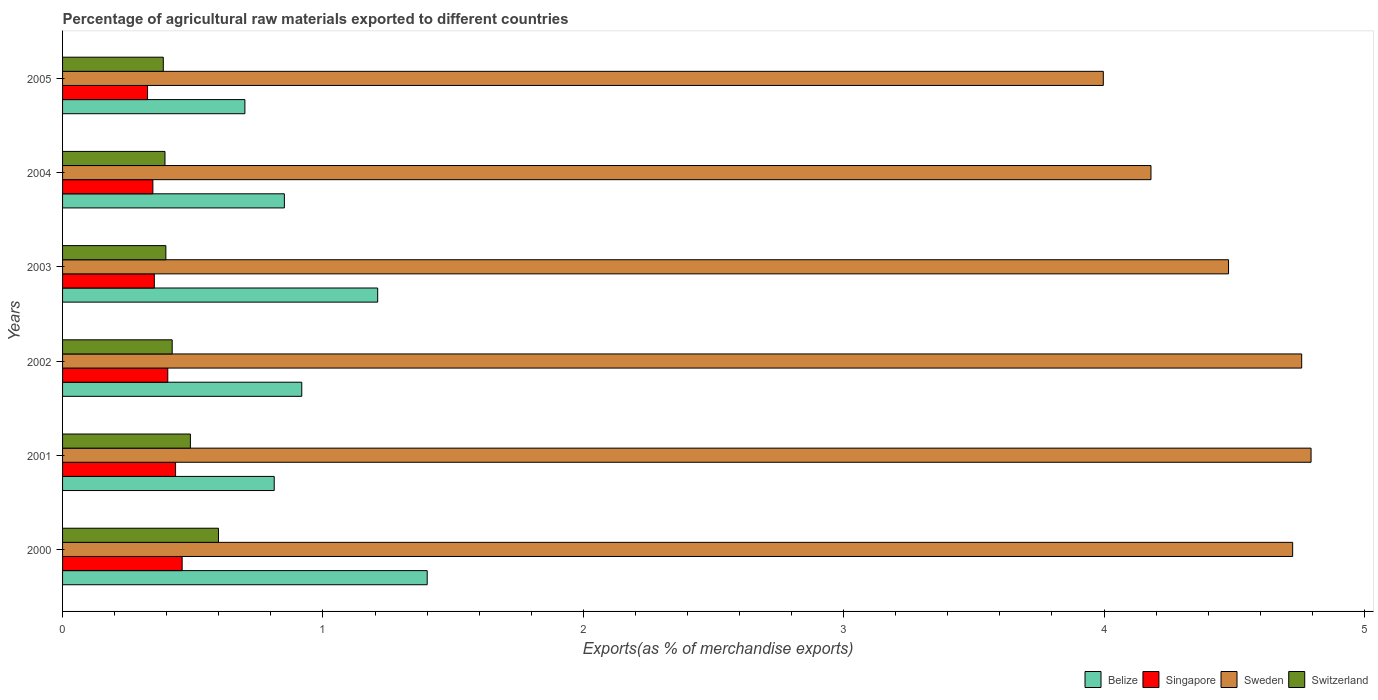How many different coloured bars are there?
Keep it short and to the point. 4. Are the number of bars per tick equal to the number of legend labels?
Make the answer very short. Yes. Are the number of bars on each tick of the Y-axis equal?
Give a very brief answer. Yes. How many bars are there on the 1st tick from the top?
Your answer should be very brief. 4. In how many cases, is the number of bars for a given year not equal to the number of legend labels?
Offer a terse response. 0. What is the percentage of exports to different countries in Sweden in 2004?
Ensure brevity in your answer.  4.18. Across all years, what is the maximum percentage of exports to different countries in Switzerland?
Provide a succinct answer. 0.6. Across all years, what is the minimum percentage of exports to different countries in Sweden?
Give a very brief answer. 4. In which year was the percentage of exports to different countries in Sweden minimum?
Keep it short and to the point. 2005. What is the total percentage of exports to different countries in Singapore in the graph?
Your response must be concise. 2.32. What is the difference between the percentage of exports to different countries in Singapore in 2001 and that in 2005?
Your answer should be very brief. 0.11. What is the difference between the percentage of exports to different countries in Singapore in 2000 and the percentage of exports to different countries in Sweden in 2002?
Keep it short and to the point. -4.3. What is the average percentage of exports to different countries in Sweden per year?
Your answer should be compact. 4.49. In the year 2000, what is the difference between the percentage of exports to different countries in Belize and percentage of exports to different countries in Singapore?
Your answer should be very brief. 0.94. What is the ratio of the percentage of exports to different countries in Singapore in 2002 to that in 2005?
Offer a very short reply. 1.24. Is the percentage of exports to different countries in Sweden in 2000 less than that in 2003?
Your answer should be very brief. No. Is the difference between the percentage of exports to different countries in Belize in 2001 and 2005 greater than the difference between the percentage of exports to different countries in Singapore in 2001 and 2005?
Make the answer very short. Yes. What is the difference between the highest and the second highest percentage of exports to different countries in Singapore?
Make the answer very short. 0.03. What is the difference between the highest and the lowest percentage of exports to different countries in Sweden?
Offer a terse response. 0.8. In how many years, is the percentage of exports to different countries in Switzerland greater than the average percentage of exports to different countries in Switzerland taken over all years?
Offer a very short reply. 2. Is it the case that in every year, the sum of the percentage of exports to different countries in Switzerland and percentage of exports to different countries in Sweden is greater than the sum of percentage of exports to different countries in Belize and percentage of exports to different countries in Singapore?
Provide a short and direct response. Yes. What does the 1st bar from the top in 2001 represents?
Provide a succinct answer. Switzerland. What does the 2nd bar from the bottom in 2003 represents?
Give a very brief answer. Singapore. How many bars are there?
Give a very brief answer. 24. How many years are there in the graph?
Provide a succinct answer. 6. Are the values on the major ticks of X-axis written in scientific E-notation?
Give a very brief answer. No. Does the graph contain grids?
Your answer should be compact. No. Where does the legend appear in the graph?
Your answer should be compact. Bottom right. How many legend labels are there?
Ensure brevity in your answer.  4. What is the title of the graph?
Offer a terse response. Percentage of agricultural raw materials exported to different countries. What is the label or title of the X-axis?
Provide a short and direct response. Exports(as % of merchandise exports). What is the Exports(as % of merchandise exports) of Belize in 2000?
Make the answer very short. 1.4. What is the Exports(as % of merchandise exports) of Singapore in 2000?
Make the answer very short. 0.46. What is the Exports(as % of merchandise exports) of Sweden in 2000?
Your response must be concise. 4.72. What is the Exports(as % of merchandise exports) of Switzerland in 2000?
Ensure brevity in your answer.  0.6. What is the Exports(as % of merchandise exports) of Belize in 2001?
Offer a terse response. 0.81. What is the Exports(as % of merchandise exports) of Singapore in 2001?
Ensure brevity in your answer.  0.43. What is the Exports(as % of merchandise exports) in Sweden in 2001?
Give a very brief answer. 4.8. What is the Exports(as % of merchandise exports) in Switzerland in 2001?
Offer a very short reply. 0.49. What is the Exports(as % of merchandise exports) of Belize in 2002?
Your answer should be compact. 0.92. What is the Exports(as % of merchandise exports) in Singapore in 2002?
Your answer should be very brief. 0.4. What is the Exports(as % of merchandise exports) in Sweden in 2002?
Give a very brief answer. 4.76. What is the Exports(as % of merchandise exports) in Switzerland in 2002?
Keep it short and to the point. 0.42. What is the Exports(as % of merchandise exports) in Belize in 2003?
Provide a succinct answer. 1.21. What is the Exports(as % of merchandise exports) of Singapore in 2003?
Your answer should be compact. 0.35. What is the Exports(as % of merchandise exports) in Sweden in 2003?
Your response must be concise. 4.48. What is the Exports(as % of merchandise exports) of Switzerland in 2003?
Provide a succinct answer. 0.4. What is the Exports(as % of merchandise exports) in Belize in 2004?
Offer a terse response. 0.85. What is the Exports(as % of merchandise exports) in Singapore in 2004?
Give a very brief answer. 0.35. What is the Exports(as % of merchandise exports) of Sweden in 2004?
Keep it short and to the point. 4.18. What is the Exports(as % of merchandise exports) in Switzerland in 2004?
Ensure brevity in your answer.  0.39. What is the Exports(as % of merchandise exports) of Belize in 2005?
Keep it short and to the point. 0.7. What is the Exports(as % of merchandise exports) of Singapore in 2005?
Provide a short and direct response. 0.33. What is the Exports(as % of merchandise exports) in Sweden in 2005?
Provide a short and direct response. 4. What is the Exports(as % of merchandise exports) of Switzerland in 2005?
Offer a terse response. 0.39. Across all years, what is the maximum Exports(as % of merchandise exports) of Belize?
Your response must be concise. 1.4. Across all years, what is the maximum Exports(as % of merchandise exports) in Singapore?
Offer a terse response. 0.46. Across all years, what is the maximum Exports(as % of merchandise exports) in Sweden?
Offer a very short reply. 4.8. Across all years, what is the maximum Exports(as % of merchandise exports) of Switzerland?
Your answer should be very brief. 0.6. Across all years, what is the minimum Exports(as % of merchandise exports) of Belize?
Your response must be concise. 0.7. Across all years, what is the minimum Exports(as % of merchandise exports) of Singapore?
Your answer should be very brief. 0.33. Across all years, what is the minimum Exports(as % of merchandise exports) of Sweden?
Make the answer very short. 4. Across all years, what is the minimum Exports(as % of merchandise exports) of Switzerland?
Your answer should be compact. 0.39. What is the total Exports(as % of merchandise exports) in Belize in the graph?
Provide a short and direct response. 5.89. What is the total Exports(as % of merchandise exports) in Singapore in the graph?
Make the answer very short. 2.32. What is the total Exports(as % of merchandise exports) in Sweden in the graph?
Your answer should be very brief. 26.93. What is the total Exports(as % of merchandise exports) in Switzerland in the graph?
Give a very brief answer. 2.69. What is the difference between the Exports(as % of merchandise exports) of Belize in 2000 and that in 2001?
Offer a very short reply. 0.59. What is the difference between the Exports(as % of merchandise exports) of Singapore in 2000 and that in 2001?
Offer a very short reply. 0.03. What is the difference between the Exports(as % of merchandise exports) in Sweden in 2000 and that in 2001?
Offer a terse response. -0.07. What is the difference between the Exports(as % of merchandise exports) in Switzerland in 2000 and that in 2001?
Provide a short and direct response. 0.11. What is the difference between the Exports(as % of merchandise exports) of Belize in 2000 and that in 2002?
Ensure brevity in your answer.  0.48. What is the difference between the Exports(as % of merchandise exports) of Singapore in 2000 and that in 2002?
Make the answer very short. 0.06. What is the difference between the Exports(as % of merchandise exports) in Sweden in 2000 and that in 2002?
Provide a short and direct response. -0.03. What is the difference between the Exports(as % of merchandise exports) of Switzerland in 2000 and that in 2002?
Your response must be concise. 0.18. What is the difference between the Exports(as % of merchandise exports) of Belize in 2000 and that in 2003?
Offer a very short reply. 0.19. What is the difference between the Exports(as % of merchandise exports) in Singapore in 2000 and that in 2003?
Ensure brevity in your answer.  0.11. What is the difference between the Exports(as % of merchandise exports) of Sweden in 2000 and that in 2003?
Your response must be concise. 0.25. What is the difference between the Exports(as % of merchandise exports) in Switzerland in 2000 and that in 2003?
Offer a terse response. 0.2. What is the difference between the Exports(as % of merchandise exports) in Belize in 2000 and that in 2004?
Provide a succinct answer. 0.55. What is the difference between the Exports(as % of merchandise exports) in Singapore in 2000 and that in 2004?
Your answer should be very brief. 0.11. What is the difference between the Exports(as % of merchandise exports) of Sweden in 2000 and that in 2004?
Your answer should be very brief. 0.54. What is the difference between the Exports(as % of merchandise exports) of Switzerland in 2000 and that in 2004?
Provide a short and direct response. 0.21. What is the difference between the Exports(as % of merchandise exports) in Belize in 2000 and that in 2005?
Offer a terse response. 0.7. What is the difference between the Exports(as % of merchandise exports) in Singapore in 2000 and that in 2005?
Offer a terse response. 0.13. What is the difference between the Exports(as % of merchandise exports) in Sweden in 2000 and that in 2005?
Make the answer very short. 0.73. What is the difference between the Exports(as % of merchandise exports) of Switzerland in 2000 and that in 2005?
Provide a succinct answer. 0.21. What is the difference between the Exports(as % of merchandise exports) in Belize in 2001 and that in 2002?
Ensure brevity in your answer.  -0.11. What is the difference between the Exports(as % of merchandise exports) in Singapore in 2001 and that in 2002?
Your response must be concise. 0.03. What is the difference between the Exports(as % of merchandise exports) in Sweden in 2001 and that in 2002?
Your answer should be compact. 0.04. What is the difference between the Exports(as % of merchandise exports) in Switzerland in 2001 and that in 2002?
Give a very brief answer. 0.07. What is the difference between the Exports(as % of merchandise exports) in Belize in 2001 and that in 2003?
Your response must be concise. -0.4. What is the difference between the Exports(as % of merchandise exports) in Singapore in 2001 and that in 2003?
Your answer should be very brief. 0.08. What is the difference between the Exports(as % of merchandise exports) of Sweden in 2001 and that in 2003?
Your answer should be compact. 0.32. What is the difference between the Exports(as % of merchandise exports) of Switzerland in 2001 and that in 2003?
Make the answer very short. 0.09. What is the difference between the Exports(as % of merchandise exports) of Belize in 2001 and that in 2004?
Your response must be concise. -0.04. What is the difference between the Exports(as % of merchandise exports) of Singapore in 2001 and that in 2004?
Your response must be concise. 0.09. What is the difference between the Exports(as % of merchandise exports) in Sweden in 2001 and that in 2004?
Make the answer very short. 0.61. What is the difference between the Exports(as % of merchandise exports) of Switzerland in 2001 and that in 2004?
Your answer should be compact. 0.1. What is the difference between the Exports(as % of merchandise exports) of Belize in 2001 and that in 2005?
Your answer should be compact. 0.11. What is the difference between the Exports(as % of merchandise exports) in Singapore in 2001 and that in 2005?
Offer a terse response. 0.11. What is the difference between the Exports(as % of merchandise exports) in Sweden in 2001 and that in 2005?
Keep it short and to the point. 0.8. What is the difference between the Exports(as % of merchandise exports) of Switzerland in 2001 and that in 2005?
Keep it short and to the point. 0.1. What is the difference between the Exports(as % of merchandise exports) in Belize in 2002 and that in 2003?
Your answer should be compact. -0.29. What is the difference between the Exports(as % of merchandise exports) in Singapore in 2002 and that in 2003?
Your answer should be very brief. 0.05. What is the difference between the Exports(as % of merchandise exports) of Sweden in 2002 and that in 2003?
Your answer should be compact. 0.28. What is the difference between the Exports(as % of merchandise exports) in Switzerland in 2002 and that in 2003?
Make the answer very short. 0.02. What is the difference between the Exports(as % of merchandise exports) of Belize in 2002 and that in 2004?
Offer a terse response. 0.07. What is the difference between the Exports(as % of merchandise exports) of Singapore in 2002 and that in 2004?
Your answer should be compact. 0.06. What is the difference between the Exports(as % of merchandise exports) of Sweden in 2002 and that in 2004?
Ensure brevity in your answer.  0.58. What is the difference between the Exports(as % of merchandise exports) in Switzerland in 2002 and that in 2004?
Keep it short and to the point. 0.03. What is the difference between the Exports(as % of merchandise exports) in Belize in 2002 and that in 2005?
Your answer should be compact. 0.22. What is the difference between the Exports(as % of merchandise exports) of Singapore in 2002 and that in 2005?
Make the answer very short. 0.08. What is the difference between the Exports(as % of merchandise exports) in Sweden in 2002 and that in 2005?
Your response must be concise. 0.76. What is the difference between the Exports(as % of merchandise exports) in Switzerland in 2002 and that in 2005?
Your answer should be compact. 0.03. What is the difference between the Exports(as % of merchandise exports) in Belize in 2003 and that in 2004?
Your answer should be compact. 0.36. What is the difference between the Exports(as % of merchandise exports) in Singapore in 2003 and that in 2004?
Your answer should be very brief. 0.01. What is the difference between the Exports(as % of merchandise exports) of Sweden in 2003 and that in 2004?
Offer a terse response. 0.3. What is the difference between the Exports(as % of merchandise exports) of Switzerland in 2003 and that in 2004?
Provide a short and direct response. 0. What is the difference between the Exports(as % of merchandise exports) in Belize in 2003 and that in 2005?
Offer a terse response. 0.51. What is the difference between the Exports(as % of merchandise exports) of Singapore in 2003 and that in 2005?
Provide a short and direct response. 0.03. What is the difference between the Exports(as % of merchandise exports) in Sweden in 2003 and that in 2005?
Your answer should be compact. 0.48. What is the difference between the Exports(as % of merchandise exports) in Switzerland in 2003 and that in 2005?
Your response must be concise. 0.01. What is the difference between the Exports(as % of merchandise exports) in Belize in 2004 and that in 2005?
Give a very brief answer. 0.15. What is the difference between the Exports(as % of merchandise exports) of Singapore in 2004 and that in 2005?
Keep it short and to the point. 0.02. What is the difference between the Exports(as % of merchandise exports) of Sweden in 2004 and that in 2005?
Keep it short and to the point. 0.18. What is the difference between the Exports(as % of merchandise exports) of Switzerland in 2004 and that in 2005?
Offer a terse response. 0.01. What is the difference between the Exports(as % of merchandise exports) of Belize in 2000 and the Exports(as % of merchandise exports) of Singapore in 2001?
Your answer should be very brief. 0.97. What is the difference between the Exports(as % of merchandise exports) of Belize in 2000 and the Exports(as % of merchandise exports) of Sweden in 2001?
Your answer should be very brief. -3.39. What is the difference between the Exports(as % of merchandise exports) in Belize in 2000 and the Exports(as % of merchandise exports) in Switzerland in 2001?
Ensure brevity in your answer.  0.91. What is the difference between the Exports(as % of merchandise exports) in Singapore in 2000 and the Exports(as % of merchandise exports) in Sweden in 2001?
Keep it short and to the point. -4.34. What is the difference between the Exports(as % of merchandise exports) in Singapore in 2000 and the Exports(as % of merchandise exports) in Switzerland in 2001?
Make the answer very short. -0.03. What is the difference between the Exports(as % of merchandise exports) of Sweden in 2000 and the Exports(as % of merchandise exports) of Switzerland in 2001?
Your answer should be compact. 4.23. What is the difference between the Exports(as % of merchandise exports) in Belize in 2000 and the Exports(as % of merchandise exports) in Singapore in 2002?
Provide a short and direct response. 1. What is the difference between the Exports(as % of merchandise exports) in Belize in 2000 and the Exports(as % of merchandise exports) in Sweden in 2002?
Offer a very short reply. -3.36. What is the difference between the Exports(as % of merchandise exports) in Belize in 2000 and the Exports(as % of merchandise exports) in Switzerland in 2002?
Your response must be concise. 0.98. What is the difference between the Exports(as % of merchandise exports) of Singapore in 2000 and the Exports(as % of merchandise exports) of Sweden in 2002?
Make the answer very short. -4.3. What is the difference between the Exports(as % of merchandise exports) in Singapore in 2000 and the Exports(as % of merchandise exports) in Switzerland in 2002?
Your response must be concise. 0.04. What is the difference between the Exports(as % of merchandise exports) in Sweden in 2000 and the Exports(as % of merchandise exports) in Switzerland in 2002?
Your response must be concise. 4.3. What is the difference between the Exports(as % of merchandise exports) in Belize in 2000 and the Exports(as % of merchandise exports) in Singapore in 2003?
Make the answer very short. 1.05. What is the difference between the Exports(as % of merchandise exports) of Belize in 2000 and the Exports(as % of merchandise exports) of Sweden in 2003?
Your response must be concise. -3.08. What is the difference between the Exports(as % of merchandise exports) in Singapore in 2000 and the Exports(as % of merchandise exports) in Sweden in 2003?
Provide a succinct answer. -4.02. What is the difference between the Exports(as % of merchandise exports) in Singapore in 2000 and the Exports(as % of merchandise exports) in Switzerland in 2003?
Provide a succinct answer. 0.06. What is the difference between the Exports(as % of merchandise exports) of Sweden in 2000 and the Exports(as % of merchandise exports) of Switzerland in 2003?
Offer a very short reply. 4.33. What is the difference between the Exports(as % of merchandise exports) of Belize in 2000 and the Exports(as % of merchandise exports) of Singapore in 2004?
Your answer should be compact. 1.05. What is the difference between the Exports(as % of merchandise exports) of Belize in 2000 and the Exports(as % of merchandise exports) of Sweden in 2004?
Make the answer very short. -2.78. What is the difference between the Exports(as % of merchandise exports) of Singapore in 2000 and the Exports(as % of merchandise exports) of Sweden in 2004?
Provide a short and direct response. -3.72. What is the difference between the Exports(as % of merchandise exports) in Singapore in 2000 and the Exports(as % of merchandise exports) in Switzerland in 2004?
Ensure brevity in your answer.  0.07. What is the difference between the Exports(as % of merchandise exports) in Sweden in 2000 and the Exports(as % of merchandise exports) in Switzerland in 2004?
Ensure brevity in your answer.  4.33. What is the difference between the Exports(as % of merchandise exports) of Belize in 2000 and the Exports(as % of merchandise exports) of Singapore in 2005?
Ensure brevity in your answer.  1.07. What is the difference between the Exports(as % of merchandise exports) of Belize in 2000 and the Exports(as % of merchandise exports) of Sweden in 2005?
Provide a short and direct response. -2.6. What is the difference between the Exports(as % of merchandise exports) in Belize in 2000 and the Exports(as % of merchandise exports) in Switzerland in 2005?
Provide a succinct answer. 1.01. What is the difference between the Exports(as % of merchandise exports) of Singapore in 2000 and the Exports(as % of merchandise exports) of Sweden in 2005?
Keep it short and to the point. -3.54. What is the difference between the Exports(as % of merchandise exports) in Singapore in 2000 and the Exports(as % of merchandise exports) in Switzerland in 2005?
Offer a very short reply. 0.07. What is the difference between the Exports(as % of merchandise exports) in Sweden in 2000 and the Exports(as % of merchandise exports) in Switzerland in 2005?
Make the answer very short. 4.34. What is the difference between the Exports(as % of merchandise exports) in Belize in 2001 and the Exports(as % of merchandise exports) in Singapore in 2002?
Your response must be concise. 0.41. What is the difference between the Exports(as % of merchandise exports) in Belize in 2001 and the Exports(as % of merchandise exports) in Sweden in 2002?
Give a very brief answer. -3.95. What is the difference between the Exports(as % of merchandise exports) of Belize in 2001 and the Exports(as % of merchandise exports) of Switzerland in 2002?
Your answer should be very brief. 0.39. What is the difference between the Exports(as % of merchandise exports) in Singapore in 2001 and the Exports(as % of merchandise exports) in Sweden in 2002?
Keep it short and to the point. -4.33. What is the difference between the Exports(as % of merchandise exports) of Singapore in 2001 and the Exports(as % of merchandise exports) of Switzerland in 2002?
Offer a terse response. 0.01. What is the difference between the Exports(as % of merchandise exports) in Sweden in 2001 and the Exports(as % of merchandise exports) in Switzerland in 2002?
Provide a short and direct response. 4.37. What is the difference between the Exports(as % of merchandise exports) of Belize in 2001 and the Exports(as % of merchandise exports) of Singapore in 2003?
Ensure brevity in your answer.  0.46. What is the difference between the Exports(as % of merchandise exports) in Belize in 2001 and the Exports(as % of merchandise exports) in Sweden in 2003?
Keep it short and to the point. -3.67. What is the difference between the Exports(as % of merchandise exports) of Belize in 2001 and the Exports(as % of merchandise exports) of Switzerland in 2003?
Offer a very short reply. 0.42. What is the difference between the Exports(as % of merchandise exports) of Singapore in 2001 and the Exports(as % of merchandise exports) of Sweden in 2003?
Your response must be concise. -4.04. What is the difference between the Exports(as % of merchandise exports) of Singapore in 2001 and the Exports(as % of merchandise exports) of Switzerland in 2003?
Ensure brevity in your answer.  0.04. What is the difference between the Exports(as % of merchandise exports) of Sweden in 2001 and the Exports(as % of merchandise exports) of Switzerland in 2003?
Your response must be concise. 4.4. What is the difference between the Exports(as % of merchandise exports) in Belize in 2001 and the Exports(as % of merchandise exports) in Singapore in 2004?
Your answer should be compact. 0.47. What is the difference between the Exports(as % of merchandise exports) in Belize in 2001 and the Exports(as % of merchandise exports) in Sweden in 2004?
Provide a succinct answer. -3.37. What is the difference between the Exports(as % of merchandise exports) in Belize in 2001 and the Exports(as % of merchandise exports) in Switzerland in 2004?
Offer a very short reply. 0.42. What is the difference between the Exports(as % of merchandise exports) in Singapore in 2001 and the Exports(as % of merchandise exports) in Sweden in 2004?
Make the answer very short. -3.75. What is the difference between the Exports(as % of merchandise exports) of Singapore in 2001 and the Exports(as % of merchandise exports) of Switzerland in 2004?
Offer a terse response. 0.04. What is the difference between the Exports(as % of merchandise exports) of Sweden in 2001 and the Exports(as % of merchandise exports) of Switzerland in 2004?
Keep it short and to the point. 4.4. What is the difference between the Exports(as % of merchandise exports) of Belize in 2001 and the Exports(as % of merchandise exports) of Singapore in 2005?
Make the answer very short. 0.49. What is the difference between the Exports(as % of merchandise exports) of Belize in 2001 and the Exports(as % of merchandise exports) of Sweden in 2005?
Your response must be concise. -3.18. What is the difference between the Exports(as % of merchandise exports) in Belize in 2001 and the Exports(as % of merchandise exports) in Switzerland in 2005?
Keep it short and to the point. 0.43. What is the difference between the Exports(as % of merchandise exports) in Singapore in 2001 and the Exports(as % of merchandise exports) in Sweden in 2005?
Your response must be concise. -3.56. What is the difference between the Exports(as % of merchandise exports) in Singapore in 2001 and the Exports(as % of merchandise exports) in Switzerland in 2005?
Give a very brief answer. 0.05. What is the difference between the Exports(as % of merchandise exports) in Sweden in 2001 and the Exports(as % of merchandise exports) in Switzerland in 2005?
Your answer should be very brief. 4.41. What is the difference between the Exports(as % of merchandise exports) of Belize in 2002 and the Exports(as % of merchandise exports) of Singapore in 2003?
Offer a terse response. 0.57. What is the difference between the Exports(as % of merchandise exports) in Belize in 2002 and the Exports(as % of merchandise exports) in Sweden in 2003?
Your response must be concise. -3.56. What is the difference between the Exports(as % of merchandise exports) in Belize in 2002 and the Exports(as % of merchandise exports) in Switzerland in 2003?
Your answer should be very brief. 0.52. What is the difference between the Exports(as % of merchandise exports) of Singapore in 2002 and the Exports(as % of merchandise exports) of Sweden in 2003?
Make the answer very short. -4.07. What is the difference between the Exports(as % of merchandise exports) in Singapore in 2002 and the Exports(as % of merchandise exports) in Switzerland in 2003?
Keep it short and to the point. 0.01. What is the difference between the Exports(as % of merchandise exports) of Sweden in 2002 and the Exports(as % of merchandise exports) of Switzerland in 2003?
Provide a short and direct response. 4.36. What is the difference between the Exports(as % of merchandise exports) of Belize in 2002 and the Exports(as % of merchandise exports) of Singapore in 2004?
Provide a short and direct response. 0.57. What is the difference between the Exports(as % of merchandise exports) in Belize in 2002 and the Exports(as % of merchandise exports) in Sweden in 2004?
Give a very brief answer. -3.26. What is the difference between the Exports(as % of merchandise exports) in Belize in 2002 and the Exports(as % of merchandise exports) in Switzerland in 2004?
Keep it short and to the point. 0.53. What is the difference between the Exports(as % of merchandise exports) of Singapore in 2002 and the Exports(as % of merchandise exports) of Sweden in 2004?
Offer a terse response. -3.78. What is the difference between the Exports(as % of merchandise exports) of Singapore in 2002 and the Exports(as % of merchandise exports) of Switzerland in 2004?
Ensure brevity in your answer.  0.01. What is the difference between the Exports(as % of merchandise exports) of Sweden in 2002 and the Exports(as % of merchandise exports) of Switzerland in 2004?
Offer a terse response. 4.37. What is the difference between the Exports(as % of merchandise exports) in Belize in 2002 and the Exports(as % of merchandise exports) in Singapore in 2005?
Offer a very short reply. 0.59. What is the difference between the Exports(as % of merchandise exports) in Belize in 2002 and the Exports(as % of merchandise exports) in Sweden in 2005?
Provide a succinct answer. -3.08. What is the difference between the Exports(as % of merchandise exports) in Belize in 2002 and the Exports(as % of merchandise exports) in Switzerland in 2005?
Your answer should be very brief. 0.53. What is the difference between the Exports(as % of merchandise exports) of Singapore in 2002 and the Exports(as % of merchandise exports) of Sweden in 2005?
Offer a terse response. -3.59. What is the difference between the Exports(as % of merchandise exports) of Singapore in 2002 and the Exports(as % of merchandise exports) of Switzerland in 2005?
Offer a terse response. 0.02. What is the difference between the Exports(as % of merchandise exports) in Sweden in 2002 and the Exports(as % of merchandise exports) in Switzerland in 2005?
Provide a short and direct response. 4.37. What is the difference between the Exports(as % of merchandise exports) in Belize in 2003 and the Exports(as % of merchandise exports) in Singapore in 2004?
Provide a short and direct response. 0.86. What is the difference between the Exports(as % of merchandise exports) in Belize in 2003 and the Exports(as % of merchandise exports) in Sweden in 2004?
Your response must be concise. -2.97. What is the difference between the Exports(as % of merchandise exports) in Belize in 2003 and the Exports(as % of merchandise exports) in Switzerland in 2004?
Keep it short and to the point. 0.82. What is the difference between the Exports(as % of merchandise exports) in Singapore in 2003 and the Exports(as % of merchandise exports) in Sweden in 2004?
Give a very brief answer. -3.83. What is the difference between the Exports(as % of merchandise exports) in Singapore in 2003 and the Exports(as % of merchandise exports) in Switzerland in 2004?
Provide a succinct answer. -0.04. What is the difference between the Exports(as % of merchandise exports) in Sweden in 2003 and the Exports(as % of merchandise exports) in Switzerland in 2004?
Offer a terse response. 4.08. What is the difference between the Exports(as % of merchandise exports) in Belize in 2003 and the Exports(as % of merchandise exports) in Singapore in 2005?
Your response must be concise. 0.88. What is the difference between the Exports(as % of merchandise exports) of Belize in 2003 and the Exports(as % of merchandise exports) of Sweden in 2005?
Your answer should be compact. -2.79. What is the difference between the Exports(as % of merchandise exports) of Belize in 2003 and the Exports(as % of merchandise exports) of Switzerland in 2005?
Ensure brevity in your answer.  0.82. What is the difference between the Exports(as % of merchandise exports) in Singapore in 2003 and the Exports(as % of merchandise exports) in Sweden in 2005?
Ensure brevity in your answer.  -3.64. What is the difference between the Exports(as % of merchandise exports) in Singapore in 2003 and the Exports(as % of merchandise exports) in Switzerland in 2005?
Keep it short and to the point. -0.03. What is the difference between the Exports(as % of merchandise exports) in Sweden in 2003 and the Exports(as % of merchandise exports) in Switzerland in 2005?
Give a very brief answer. 4.09. What is the difference between the Exports(as % of merchandise exports) in Belize in 2004 and the Exports(as % of merchandise exports) in Singapore in 2005?
Your response must be concise. 0.53. What is the difference between the Exports(as % of merchandise exports) in Belize in 2004 and the Exports(as % of merchandise exports) in Sweden in 2005?
Offer a terse response. -3.15. What is the difference between the Exports(as % of merchandise exports) in Belize in 2004 and the Exports(as % of merchandise exports) in Switzerland in 2005?
Provide a short and direct response. 0.47. What is the difference between the Exports(as % of merchandise exports) of Singapore in 2004 and the Exports(as % of merchandise exports) of Sweden in 2005?
Offer a very short reply. -3.65. What is the difference between the Exports(as % of merchandise exports) in Singapore in 2004 and the Exports(as % of merchandise exports) in Switzerland in 2005?
Your response must be concise. -0.04. What is the difference between the Exports(as % of merchandise exports) of Sweden in 2004 and the Exports(as % of merchandise exports) of Switzerland in 2005?
Provide a succinct answer. 3.79. What is the average Exports(as % of merchandise exports) in Belize per year?
Ensure brevity in your answer.  0.98. What is the average Exports(as % of merchandise exports) of Singapore per year?
Give a very brief answer. 0.39. What is the average Exports(as % of merchandise exports) of Sweden per year?
Provide a succinct answer. 4.49. What is the average Exports(as % of merchandise exports) in Switzerland per year?
Your answer should be compact. 0.45. In the year 2000, what is the difference between the Exports(as % of merchandise exports) in Belize and Exports(as % of merchandise exports) in Singapore?
Provide a short and direct response. 0.94. In the year 2000, what is the difference between the Exports(as % of merchandise exports) in Belize and Exports(as % of merchandise exports) in Sweden?
Provide a succinct answer. -3.32. In the year 2000, what is the difference between the Exports(as % of merchandise exports) of Belize and Exports(as % of merchandise exports) of Switzerland?
Your answer should be compact. 0.8. In the year 2000, what is the difference between the Exports(as % of merchandise exports) in Singapore and Exports(as % of merchandise exports) in Sweden?
Ensure brevity in your answer.  -4.27. In the year 2000, what is the difference between the Exports(as % of merchandise exports) of Singapore and Exports(as % of merchandise exports) of Switzerland?
Offer a terse response. -0.14. In the year 2000, what is the difference between the Exports(as % of merchandise exports) in Sweden and Exports(as % of merchandise exports) in Switzerland?
Provide a succinct answer. 4.13. In the year 2001, what is the difference between the Exports(as % of merchandise exports) of Belize and Exports(as % of merchandise exports) of Singapore?
Keep it short and to the point. 0.38. In the year 2001, what is the difference between the Exports(as % of merchandise exports) of Belize and Exports(as % of merchandise exports) of Sweden?
Offer a terse response. -3.98. In the year 2001, what is the difference between the Exports(as % of merchandise exports) of Belize and Exports(as % of merchandise exports) of Switzerland?
Give a very brief answer. 0.32. In the year 2001, what is the difference between the Exports(as % of merchandise exports) in Singapore and Exports(as % of merchandise exports) in Sweden?
Give a very brief answer. -4.36. In the year 2001, what is the difference between the Exports(as % of merchandise exports) in Singapore and Exports(as % of merchandise exports) in Switzerland?
Your answer should be very brief. -0.06. In the year 2001, what is the difference between the Exports(as % of merchandise exports) in Sweden and Exports(as % of merchandise exports) in Switzerland?
Offer a very short reply. 4.3. In the year 2002, what is the difference between the Exports(as % of merchandise exports) of Belize and Exports(as % of merchandise exports) of Singapore?
Keep it short and to the point. 0.51. In the year 2002, what is the difference between the Exports(as % of merchandise exports) in Belize and Exports(as % of merchandise exports) in Sweden?
Give a very brief answer. -3.84. In the year 2002, what is the difference between the Exports(as % of merchandise exports) of Belize and Exports(as % of merchandise exports) of Switzerland?
Provide a succinct answer. 0.5. In the year 2002, what is the difference between the Exports(as % of merchandise exports) of Singapore and Exports(as % of merchandise exports) of Sweden?
Ensure brevity in your answer.  -4.35. In the year 2002, what is the difference between the Exports(as % of merchandise exports) of Singapore and Exports(as % of merchandise exports) of Switzerland?
Your answer should be compact. -0.02. In the year 2002, what is the difference between the Exports(as % of merchandise exports) in Sweden and Exports(as % of merchandise exports) in Switzerland?
Provide a short and direct response. 4.34. In the year 2003, what is the difference between the Exports(as % of merchandise exports) of Belize and Exports(as % of merchandise exports) of Singapore?
Ensure brevity in your answer.  0.86. In the year 2003, what is the difference between the Exports(as % of merchandise exports) of Belize and Exports(as % of merchandise exports) of Sweden?
Provide a short and direct response. -3.27. In the year 2003, what is the difference between the Exports(as % of merchandise exports) of Belize and Exports(as % of merchandise exports) of Switzerland?
Your answer should be very brief. 0.81. In the year 2003, what is the difference between the Exports(as % of merchandise exports) of Singapore and Exports(as % of merchandise exports) of Sweden?
Give a very brief answer. -4.13. In the year 2003, what is the difference between the Exports(as % of merchandise exports) of Singapore and Exports(as % of merchandise exports) of Switzerland?
Your response must be concise. -0.04. In the year 2003, what is the difference between the Exports(as % of merchandise exports) in Sweden and Exports(as % of merchandise exports) in Switzerland?
Make the answer very short. 4.08. In the year 2004, what is the difference between the Exports(as % of merchandise exports) in Belize and Exports(as % of merchandise exports) in Singapore?
Ensure brevity in your answer.  0.51. In the year 2004, what is the difference between the Exports(as % of merchandise exports) of Belize and Exports(as % of merchandise exports) of Sweden?
Ensure brevity in your answer.  -3.33. In the year 2004, what is the difference between the Exports(as % of merchandise exports) of Belize and Exports(as % of merchandise exports) of Switzerland?
Make the answer very short. 0.46. In the year 2004, what is the difference between the Exports(as % of merchandise exports) in Singapore and Exports(as % of merchandise exports) in Sweden?
Your answer should be very brief. -3.83. In the year 2004, what is the difference between the Exports(as % of merchandise exports) in Singapore and Exports(as % of merchandise exports) in Switzerland?
Your response must be concise. -0.05. In the year 2004, what is the difference between the Exports(as % of merchandise exports) in Sweden and Exports(as % of merchandise exports) in Switzerland?
Your answer should be very brief. 3.79. In the year 2005, what is the difference between the Exports(as % of merchandise exports) of Belize and Exports(as % of merchandise exports) of Singapore?
Give a very brief answer. 0.37. In the year 2005, what is the difference between the Exports(as % of merchandise exports) of Belize and Exports(as % of merchandise exports) of Sweden?
Provide a short and direct response. -3.3. In the year 2005, what is the difference between the Exports(as % of merchandise exports) in Belize and Exports(as % of merchandise exports) in Switzerland?
Your answer should be compact. 0.31. In the year 2005, what is the difference between the Exports(as % of merchandise exports) of Singapore and Exports(as % of merchandise exports) of Sweden?
Your response must be concise. -3.67. In the year 2005, what is the difference between the Exports(as % of merchandise exports) in Singapore and Exports(as % of merchandise exports) in Switzerland?
Your response must be concise. -0.06. In the year 2005, what is the difference between the Exports(as % of merchandise exports) in Sweden and Exports(as % of merchandise exports) in Switzerland?
Offer a terse response. 3.61. What is the ratio of the Exports(as % of merchandise exports) in Belize in 2000 to that in 2001?
Offer a terse response. 1.72. What is the ratio of the Exports(as % of merchandise exports) in Singapore in 2000 to that in 2001?
Offer a very short reply. 1.06. What is the ratio of the Exports(as % of merchandise exports) of Sweden in 2000 to that in 2001?
Provide a succinct answer. 0.99. What is the ratio of the Exports(as % of merchandise exports) in Switzerland in 2000 to that in 2001?
Ensure brevity in your answer.  1.22. What is the ratio of the Exports(as % of merchandise exports) in Belize in 2000 to that in 2002?
Your answer should be compact. 1.52. What is the ratio of the Exports(as % of merchandise exports) in Singapore in 2000 to that in 2002?
Provide a succinct answer. 1.14. What is the ratio of the Exports(as % of merchandise exports) in Switzerland in 2000 to that in 2002?
Offer a very short reply. 1.42. What is the ratio of the Exports(as % of merchandise exports) of Belize in 2000 to that in 2003?
Provide a short and direct response. 1.16. What is the ratio of the Exports(as % of merchandise exports) of Singapore in 2000 to that in 2003?
Give a very brief answer. 1.3. What is the ratio of the Exports(as % of merchandise exports) in Sweden in 2000 to that in 2003?
Provide a succinct answer. 1.05. What is the ratio of the Exports(as % of merchandise exports) of Switzerland in 2000 to that in 2003?
Offer a terse response. 1.51. What is the ratio of the Exports(as % of merchandise exports) in Belize in 2000 to that in 2004?
Keep it short and to the point. 1.64. What is the ratio of the Exports(as % of merchandise exports) in Singapore in 2000 to that in 2004?
Your response must be concise. 1.32. What is the ratio of the Exports(as % of merchandise exports) in Sweden in 2000 to that in 2004?
Your response must be concise. 1.13. What is the ratio of the Exports(as % of merchandise exports) of Switzerland in 2000 to that in 2004?
Keep it short and to the point. 1.52. What is the ratio of the Exports(as % of merchandise exports) of Belize in 2000 to that in 2005?
Keep it short and to the point. 2. What is the ratio of the Exports(as % of merchandise exports) in Singapore in 2000 to that in 2005?
Provide a succinct answer. 1.41. What is the ratio of the Exports(as % of merchandise exports) of Sweden in 2000 to that in 2005?
Give a very brief answer. 1.18. What is the ratio of the Exports(as % of merchandise exports) of Switzerland in 2000 to that in 2005?
Make the answer very short. 1.55. What is the ratio of the Exports(as % of merchandise exports) of Belize in 2001 to that in 2002?
Provide a short and direct response. 0.88. What is the ratio of the Exports(as % of merchandise exports) of Singapore in 2001 to that in 2002?
Keep it short and to the point. 1.07. What is the ratio of the Exports(as % of merchandise exports) of Sweden in 2001 to that in 2002?
Offer a very short reply. 1.01. What is the ratio of the Exports(as % of merchandise exports) of Switzerland in 2001 to that in 2002?
Offer a terse response. 1.17. What is the ratio of the Exports(as % of merchandise exports) in Belize in 2001 to that in 2003?
Ensure brevity in your answer.  0.67. What is the ratio of the Exports(as % of merchandise exports) of Singapore in 2001 to that in 2003?
Provide a succinct answer. 1.23. What is the ratio of the Exports(as % of merchandise exports) in Sweden in 2001 to that in 2003?
Your answer should be compact. 1.07. What is the ratio of the Exports(as % of merchandise exports) in Switzerland in 2001 to that in 2003?
Offer a terse response. 1.24. What is the ratio of the Exports(as % of merchandise exports) in Belize in 2001 to that in 2004?
Give a very brief answer. 0.95. What is the ratio of the Exports(as % of merchandise exports) of Singapore in 2001 to that in 2004?
Provide a succinct answer. 1.25. What is the ratio of the Exports(as % of merchandise exports) in Sweden in 2001 to that in 2004?
Your answer should be compact. 1.15. What is the ratio of the Exports(as % of merchandise exports) of Switzerland in 2001 to that in 2004?
Your answer should be very brief. 1.25. What is the ratio of the Exports(as % of merchandise exports) in Belize in 2001 to that in 2005?
Ensure brevity in your answer.  1.16. What is the ratio of the Exports(as % of merchandise exports) in Singapore in 2001 to that in 2005?
Provide a short and direct response. 1.33. What is the ratio of the Exports(as % of merchandise exports) of Sweden in 2001 to that in 2005?
Make the answer very short. 1.2. What is the ratio of the Exports(as % of merchandise exports) in Switzerland in 2001 to that in 2005?
Provide a succinct answer. 1.27. What is the ratio of the Exports(as % of merchandise exports) of Belize in 2002 to that in 2003?
Keep it short and to the point. 0.76. What is the ratio of the Exports(as % of merchandise exports) in Singapore in 2002 to that in 2003?
Provide a succinct answer. 1.15. What is the ratio of the Exports(as % of merchandise exports) of Sweden in 2002 to that in 2003?
Give a very brief answer. 1.06. What is the ratio of the Exports(as % of merchandise exports) of Switzerland in 2002 to that in 2003?
Your answer should be very brief. 1.06. What is the ratio of the Exports(as % of merchandise exports) in Belize in 2002 to that in 2004?
Provide a short and direct response. 1.08. What is the ratio of the Exports(as % of merchandise exports) of Singapore in 2002 to that in 2004?
Your answer should be very brief. 1.17. What is the ratio of the Exports(as % of merchandise exports) of Sweden in 2002 to that in 2004?
Provide a short and direct response. 1.14. What is the ratio of the Exports(as % of merchandise exports) in Switzerland in 2002 to that in 2004?
Keep it short and to the point. 1.07. What is the ratio of the Exports(as % of merchandise exports) in Belize in 2002 to that in 2005?
Your answer should be compact. 1.31. What is the ratio of the Exports(as % of merchandise exports) of Singapore in 2002 to that in 2005?
Your answer should be very brief. 1.24. What is the ratio of the Exports(as % of merchandise exports) of Sweden in 2002 to that in 2005?
Your response must be concise. 1.19. What is the ratio of the Exports(as % of merchandise exports) of Switzerland in 2002 to that in 2005?
Give a very brief answer. 1.09. What is the ratio of the Exports(as % of merchandise exports) of Belize in 2003 to that in 2004?
Offer a terse response. 1.42. What is the ratio of the Exports(as % of merchandise exports) in Singapore in 2003 to that in 2004?
Offer a very short reply. 1.02. What is the ratio of the Exports(as % of merchandise exports) in Sweden in 2003 to that in 2004?
Provide a short and direct response. 1.07. What is the ratio of the Exports(as % of merchandise exports) of Switzerland in 2003 to that in 2004?
Keep it short and to the point. 1.01. What is the ratio of the Exports(as % of merchandise exports) of Belize in 2003 to that in 2005?
Make the answer very short. 1.73. What is the ratio of the Exports(as % of merchandise exports) of Singapore in 2003 to that in 2005?
Ensure brevity in your answer.  1.08. What is the ratio of the Exports(as % of merchandise exports) in Sweden in 2003 to that in 2005?
Offer a very short reply. 1.12. What is the ratio of the Exports(as % of merchandise exports) of Switzerland in 2003 to that in 2005?
Make the answer very short. 1.03. What is the ratio of the Exports(as % of merchandise exports) in Belize in 2004 to that in 2005?
Offer a terse response. 1.22. What is the ratio of the Exports(as % of merchandise exports) in Singapore in 2004 to that in 2005?
Provide a succinct answer. 1.06. What is the ratio of the Exports(as % of merchandise exports) in Sweden in 2004 to that in 2005?
Offer a very short reply. 1.05. What is the ratio of the Exports(as % of merchandise exports) of Switzerland in 2004 to that in 2005?
Your response must be concise. 1.02. What is the difference between the highest and the second highest Exports(as % of merchandise exports) of Belize?
Offer a very short reply. 0.19. What is the difference between the highest and the second highest Exports(as % of merchandise exports) of Singapore?
Your answer should be very brief. 0.03. What is the difference between the highest and the second highest Exports(as % of merchandise exports) of Sweden?
Give a very brief answer. 0.04. What is the difference between the highest and the second highest Exports(as % of merchandise exports) of Switzerland?
Offer a very short reply. 0.11. What is the difference between the highest and the lowest Exports(as % of merchandise exports) of Belize?
Provide a short and direct response. 0.7. What is the difference between the highest and the lowest Exports(as % of merchandise exports) of Singapore?
Offer a terse response. 0.13. What is the difference between the highest and the lowest Exports(as % of merchandise exports) of Sweden?
Provide a short and direct response. 0.8. What is the difference between the highest and the lowest Exports(as % of merchandise exports) of Switzerland?
Keep it short and to the point. 0.21. 